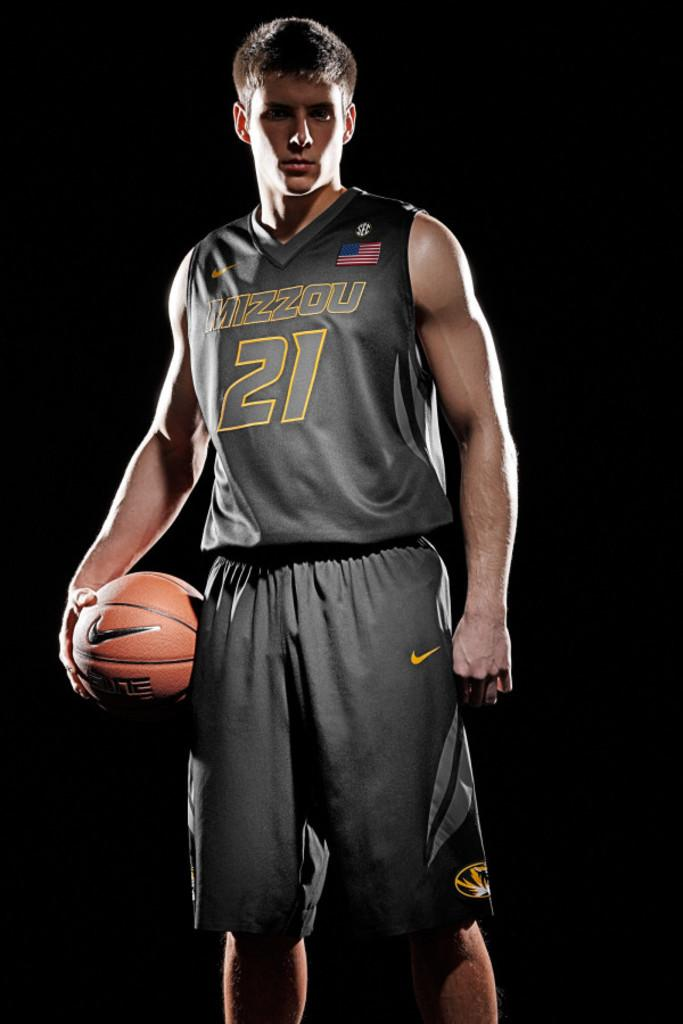<image>
Offer a succinct explanation of the picture presented. Player number 21 for Mizzou stands against a black background 